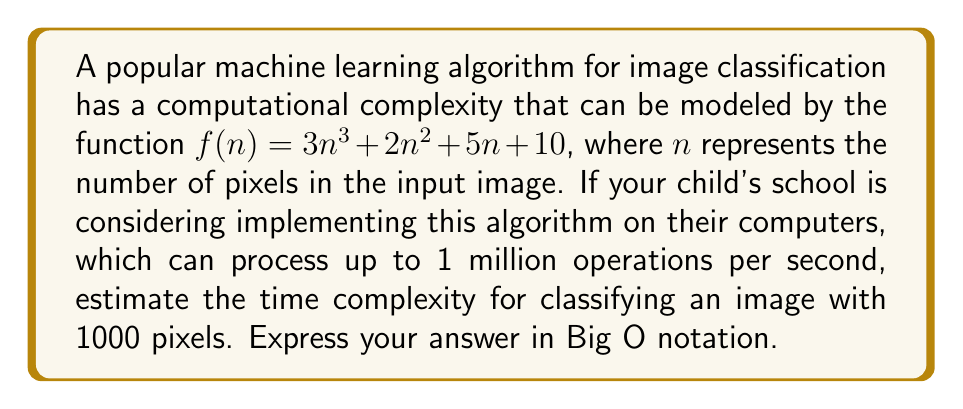Can you answer this question? To estimate the computational complexity in Big O notation, we need to follow these steps:

1) First, recall that Big O notation describes the upper bound of the growth rate of a function. It focuses on the term that grows the fastest as n approaches infinity.

2) In our function $f(n) = 3n^3 + 2n^2 + 5n + 10$, the term that grows the fastest is $3n^3$.

3) In Big O notation, we drop coefficients and lower-order terms. So $3n^3$ becomes simply $O(n^3)$.

4) Therefore, the time complexity of this algorithm is $O(n^3)$.

5) To estimate the actual time for n = 1000:
   
   $f(1000) = 3(1000)^3 + 2(1000)^2 + 5(1000) + 10$
   
   $= 3,000,000,000 + 2,000,000 + 5,000 + 10$
   
   $\approx 3,002,005,010$ operations

6) Given that the computer can process 1 million operations per second:

   Time ≈ 3,002,005,010 / 1,000,000 ≈ 3002 seconds ≈ 50 minutes

However, the exact time is not part of the Big O notation. The key point is that the algorithm's complexity grows cubically with the input size.
Answer: $O(n^3)$ 